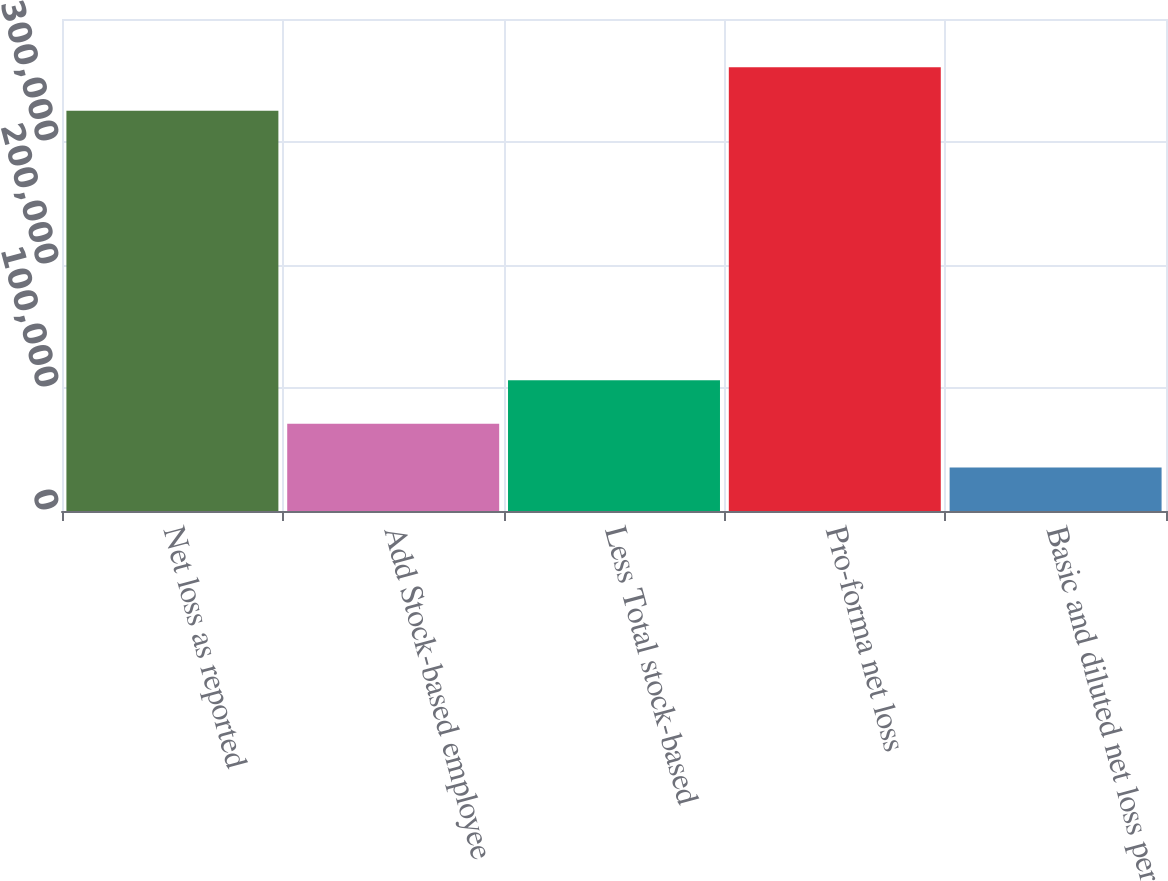Convert chart. <chart><loc_0><loc_0><loc_500><loc_500><bar_chart><fcel>Net loss as reported<fcel>Add Stock-based employee<fcel>Less Total stock-based<fcel>Pro-forma net loss<fcel>Basic and diluted net loss per<nl><fcel>325321<fcel>70881.2<fcel>106321<fcel>360761<fcel>35441.4<nl></chart> 